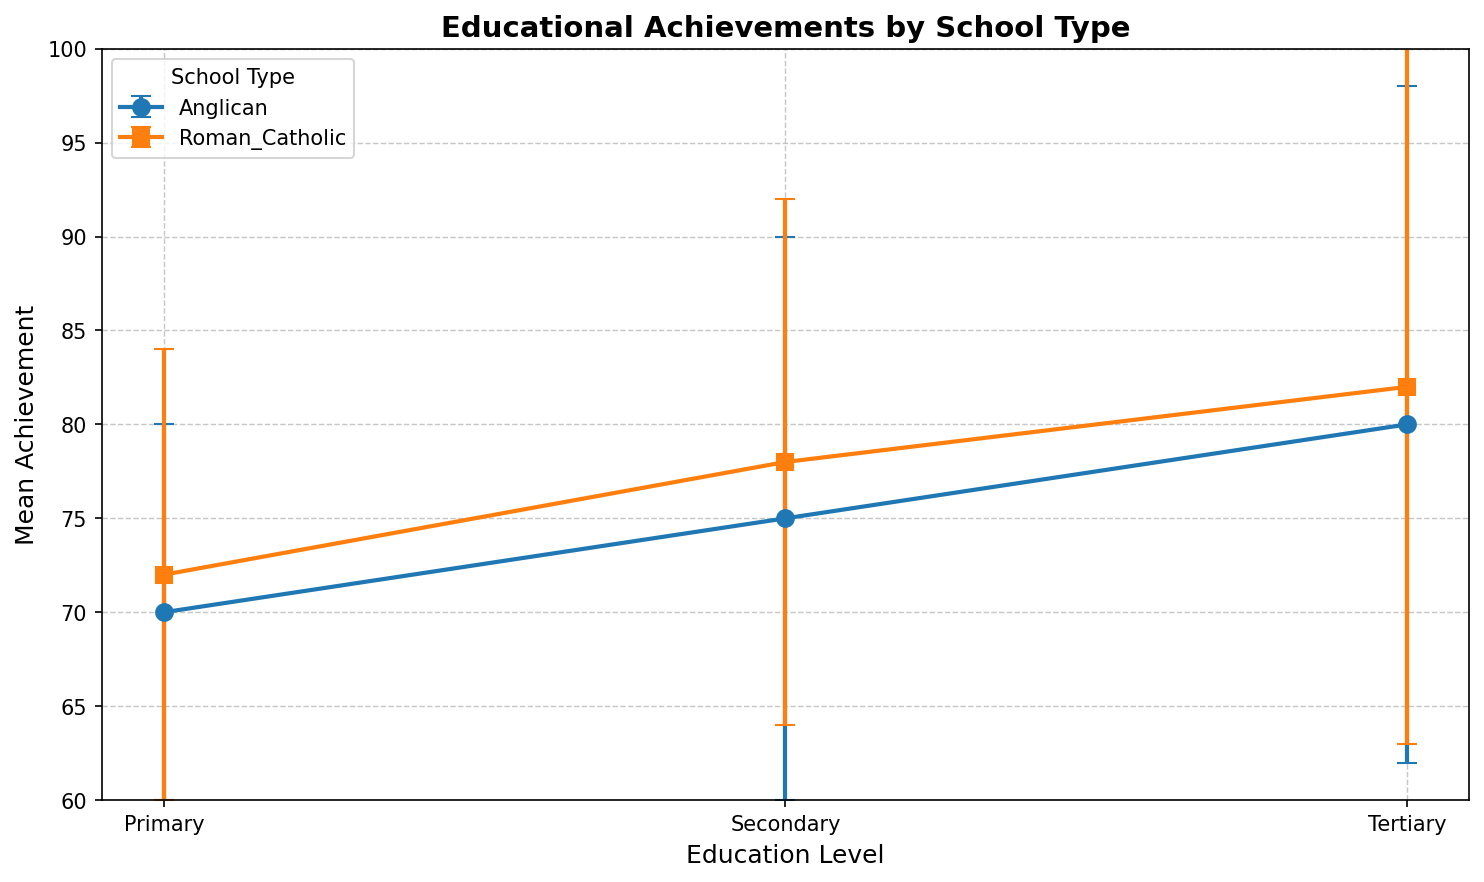What is the difference in mean achievement between Anglican and Roman Catholic schools at the primary education level? The mean achievement for Anglican schools at the primary level is 70, and for Roman Catholic schools, it is 72. The difference is 72 - 70.
Answer: 2 Which school type has a higher mean achievement in secondary education? Comparing the mean achievements, Anglican schools have 75, while Roman Catholic schools have 78 for secondary education. Roman Catholic schools have a higher mean achievement.
Answer: Roman Catholic What is the range of mean achievements for Anglican schools across all education levels? The mean achievements for Anglican schools are 70 (primary), 75 (secondary), and 80 (tertiary). The range is the difference between the highest and lowest values: 80 - 70.
Answer: 10 How much higher is the mean achievement for tertiary education compared to primary education for Roman Catholic schools? The mean achievement for tertiary education in Roman Catholic schools is 82, and for primary education, it is 72. The difference is 82 - 72.
Answer: 10 Comparing standard deviations, which education level has the lowest variability for Anglican schools? The standard deviations for Anglican schools are 10 (primary), 15 (secondary), and 18 (tertiary). The lowest standard deviation is at the primary level with 10.
Answer: Primary Which school type shows a larger increase in mean achievement from secondary to tertiary education? For Anglican schools, the increase is 80 (tertiary) - 75 (secondary) = 5. For Roman Catholic schools, the increase is 82 (tertiary) - 78 (secondary) = 4. The Anglican schools show a larger increase.
Answer: Anglican schools Is the standard deviation higher for Roman Catholic or Anglican schools at the tertiary education level? The standard deviation for Roman Catholic schools at the tertiary level is 19, and for Anglican schools, it is 18. Roman Catholic schools have a higher standard deviation.
Answer: Roman Catholic schools What is the overall average mean achievement for Roman Catholic schools across all education levels? The mean achievements are 72 (primary), 78 (secondary), and 82 (tertiary). The overall average is (72 + 78 + 82) / 3.
Answer: 77.33 By how much does the mean achievement increase from primary to tertiary education for Anglican schools? The mean achievements for Anglican schools are 70 (primary) and 80 (tertiary). The increase is 80 - 70.
Answer: 10 